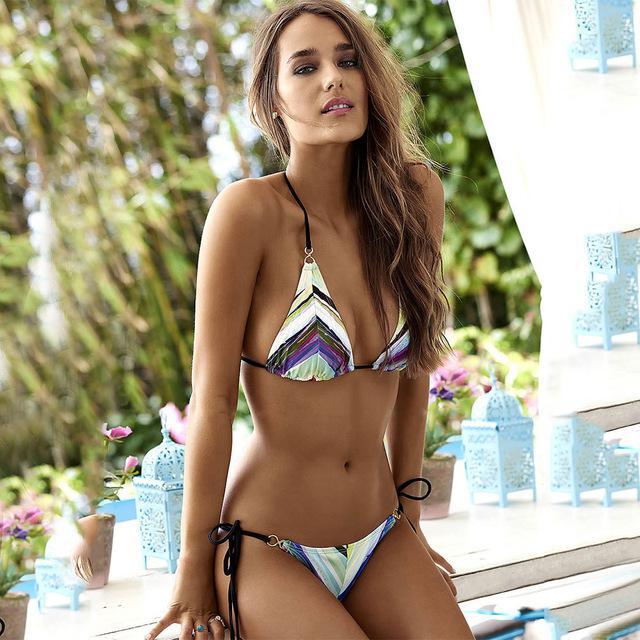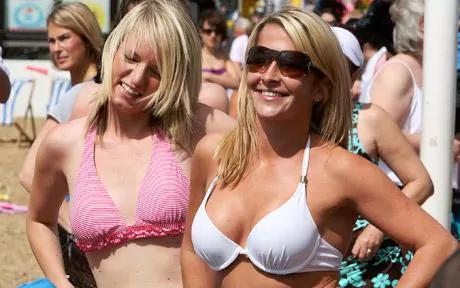The first image is the image on the left, the second image is the image on the right. Examine the images to the left and right. Is the description "At least one of the women in the image on the right is wearing sunglasses." accurate? Answer yes or no. Yes. 